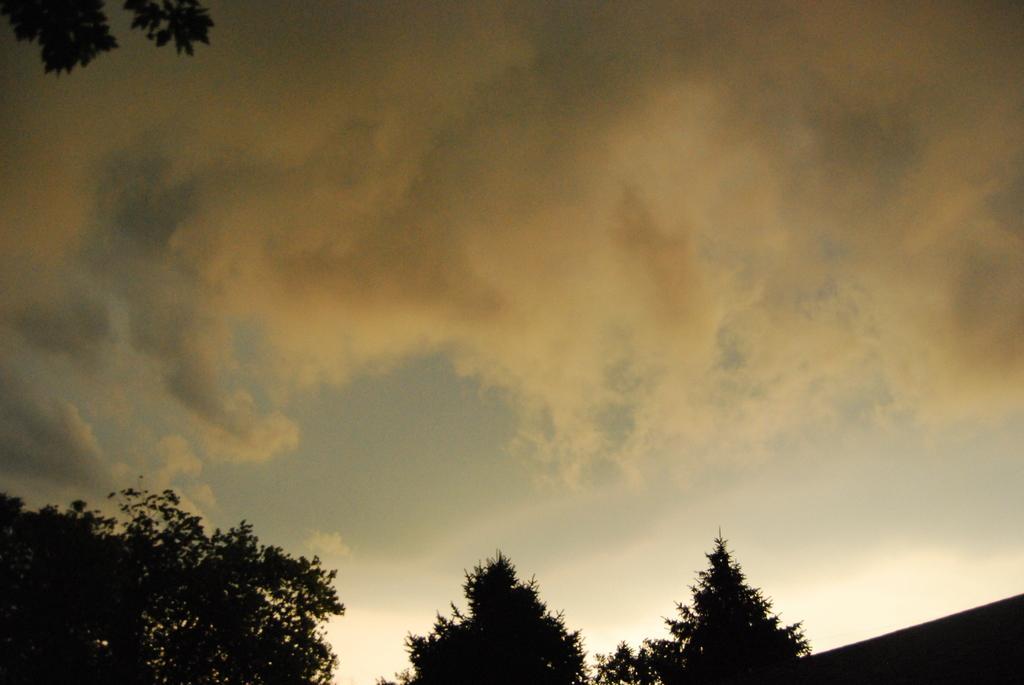In one or two sentences, can you explain what this image depicts? In this image I can see few trees and the sky is in cream, black and white color. 